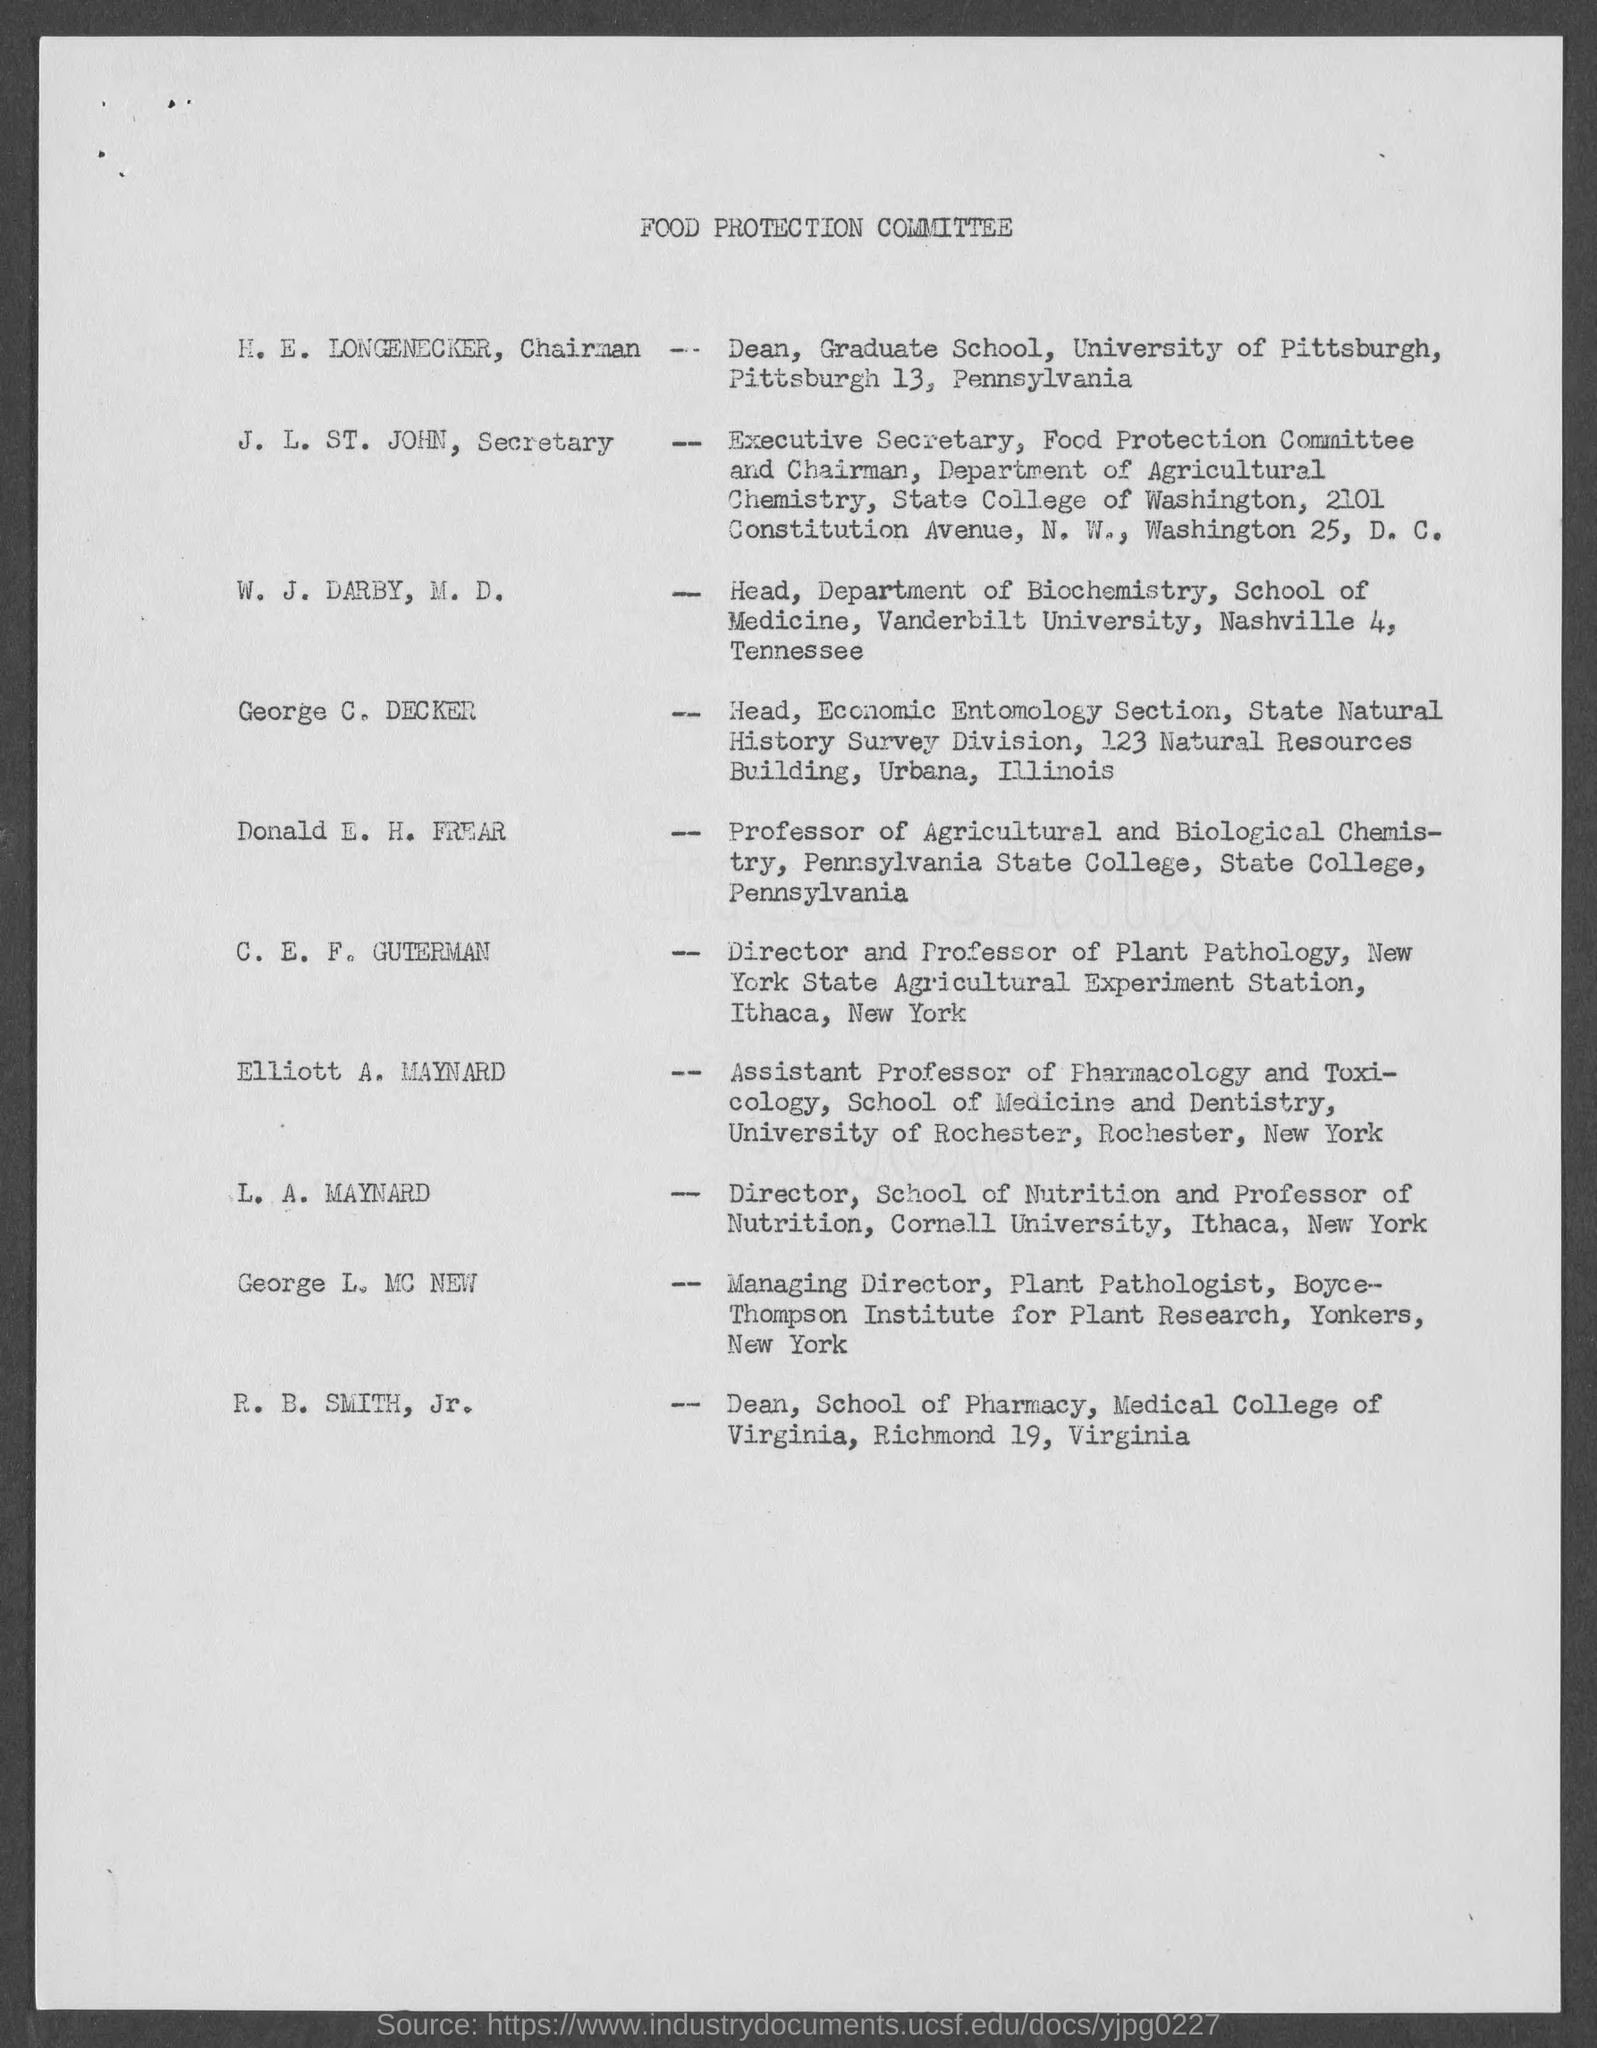Highlight a few significant elements in this photo. The individual known as Dean of the School of Pharmacy at the Medical College of Virginia is R.B. Smith, Jr. The Director and Professor of Plant Pathology at the New York State Agriculture Experiment Station is C. E. F. Guterman. I would like to inform the house that the name of the committee responsible for food protection is the Food Protection Committee. The managing director of the Boyce- Thompson Institute for Plant Research is George L. MC NEW. George C. Decker is the Head of the Economic Entomology Section of the State Natural History Survey Division. 